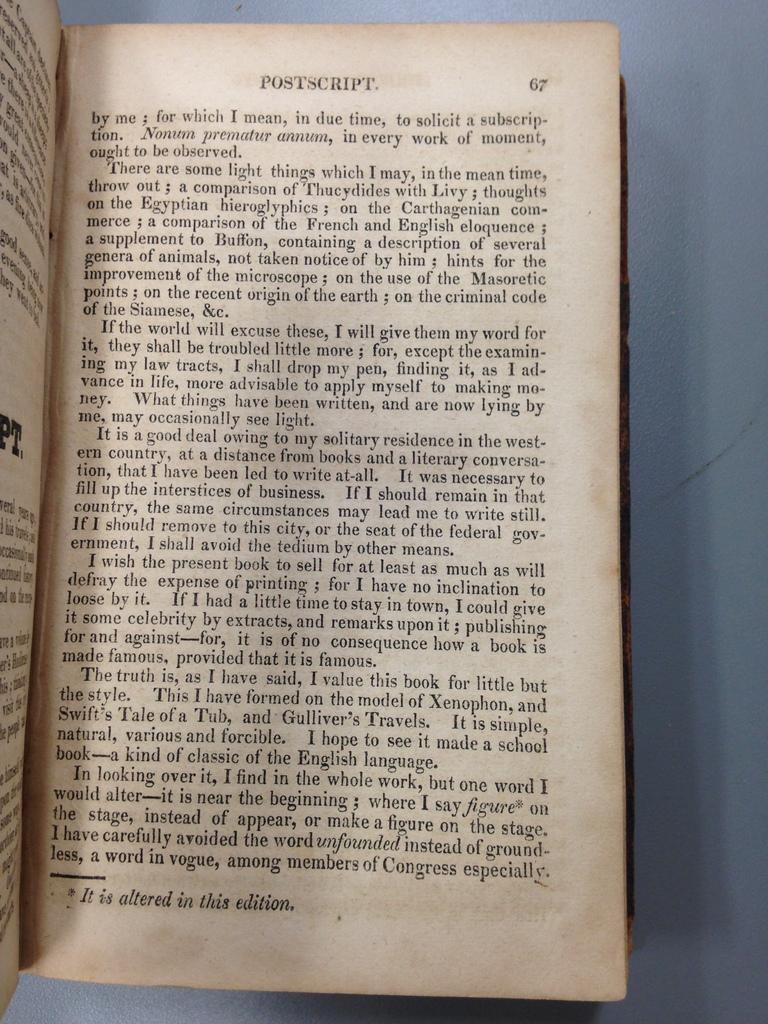What is the title of this page?
Offer a very short reply. Postscript. 